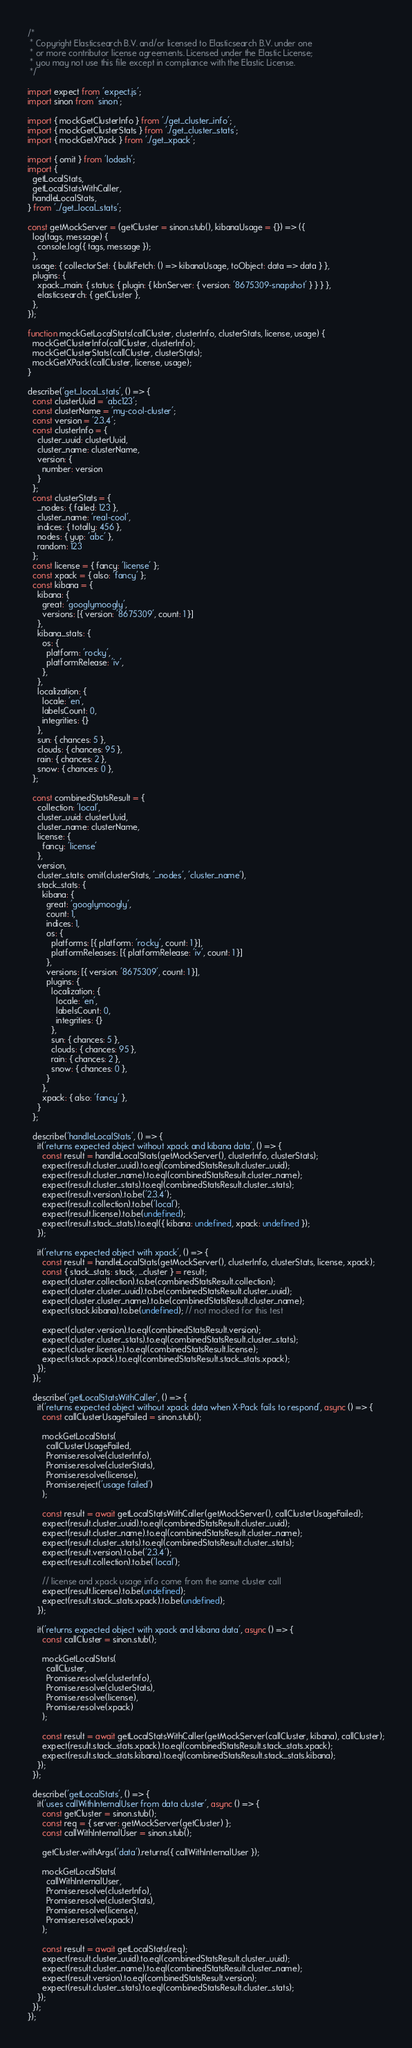<code> <loc_0><loc_0><loc_500><loc_500><_JavaScript_>/*
 * Copyright Elasticsearch B.V. and/or licensed to Elasticsearch B.V. under one
 * or more contributor license agreements. Licensed under the Elastic License;
 * you may not use this file except in compliance with the Elastic License.
 */

import expect from 'expect.js';
import sinon from 'sinon';

import { mockGetClusterInfo } from './get_cluster_info';
import { mockGetClusterStats } from './get_cluster_stats';
import { mockGetXPack } from './get_xpack';

import { omit } from 'lodash';
import {
  getLocalStats,
  getLocalStatsWithCaller,
  handleLocalStats,
} from '../get_local_stats';

const getMockServer = (getCluster = sinon.stub(), kibanaUsage = {}) => ({
  log(tags, message) {
    console.log({ tags, message });
  },
  usage: { collectorSet: { bulkFetch: () => kibanaUsage, toObject: data => data } },
  plugins: {
    xpack_main: { status: { plugin: { kbnServer: { version: '8675309-snapshot' } } } },
    elasticsearch: { getCluster },
  },
});

function mockGetLocalStats(callCluster, clusterInfo, clusterStats, license, usage) {
  mockGetClusterInfo(callCluster, clusterInfo);
  mockGetClusterStats(callCluster, clusterStats);
  mockGetXPack(callCluster, license, usage);
}

describe('get_local_stats', () => {
  const clusterUuid = 'abc123';
  const clusterName = 'my-cool-cluster';
  const version = '2.3.4';
  const clusterInfo = {
    cluster_uuid: clusterUuid,
    cluster_name: clusterName,
    version: {
      number: version
    }
  };
  const clusterStats = {
    _nodes: { failed: 123 },
    cluster_name: 'real-cool',
    indices: { totally: 456 },
    nodes: { yup: 'abc' },
    random: 123
  };
  const license = { fancy: 'license' };
  const xpack = { also: 'fancy' };
  const kibana = {
    kibana: {
      great: 'googlymoogly',
      versions: [{ version: '8675309', count: 1 }]
    },
    kibana_stats: {
      os: {
        platform: 'rocky',
        platformRelease: 'iv',
      },
    },
    localization: {
      locale: 'en',
      labelsCount: 0,
      integrities: {}
    },
    sun: { chances: 5 },
    clouds: { chances: 95 },
    rain: { chances: 2 },
    snow: { chances: 0 },
  };

  const combinedStatsResult = {
    collection: 'local',
    cluster_uuid: clusterUuid,
    cluster_name: clusterName,
    license: {
      fancy: 'license'
    },
    version,
    cluster_stats: omit(clusterStats, '_nodes', 'cluster_name'),
    stack_stats: {
      kibana: {
        great: 'googlymoogly',
        count: 1,
        indices: 1,
        os: {
          platforms: [{ platform: 'rocky', count: 1 }],
          platformReleases: [{ platformRelease: 'iv', count: 1 }]
        },
        versions: [{ version: '8675309', count: 1 }],
        plugins: {
          localization: {
            locale: 'en',
            labelsCount: 0,
            integrities: {}
          },
          sun: { chances: 5 },
          clouds: { chances: 95 },
          rain: { chances: 2 },
          snow: { chances: 0 },
        }
      },
      xpack: { also: 'fancy' },
    }
  };

  describe('handleLocalStats', () => {
    it('returns expected object without xpack and kibana data', () => {
      const result = handleLocalStats(getMockServer(), clusterInfo, clusterStats);
      expect(result.cluster_uuid).to.eql(combinedStatsResult.cluster_uuid);
      expect(result.cluster_name).to.eql(combinedStatsResult.cluster_name);
      expect(result.cluster_stats).to.eql(combinedStatsResult.cluster_stats);
      expect(result.version).to.be('2.3.4');
      expect(result.collection).to.be('local');
      expect(result.license).to.be(undefined);
      expect(result.stack_stats).to.eql({ kibana: undefined, xpack: undefined });
    });

    it('returns expected object with xpack', () => {
      const result = handleLocalStats(getMockServer(), clusterInfo, clusterStats, license, xpack);
      const { stack_stats: stack, ...cluster } = result;
      expect(cluster.collection).to.be(combinedStatsResult.collection);
      expect(cluster.cluster_uuid).to.be(combinedStatsResult.cluster_uuid);
      expect(cluster.cluster_name).to.be(combinedStatsResult.cluster_name);
      expect(stack.kibana).to.be(undefined); // not mocked for this test

      expect(cluster.version).to.eql(combinedStatsResult.version);
      expect(cluster.cluster_stats).to.eql(combinedStatsResult.cluster_stats);
      expect(cluster.license).to.eql(combinedStatsResult.license);
      expect(stack.xpack).to.eql(combinedStatsResult.stack_stats.xpack);
    });
  });

  describe('getLocalStatsWithCaller', () => {
    it('returns expected object without xpack data when X-Pack fails to respond', async () => {
      const callClusterUsageFailed = sinon.stub();

      mockGetLocalStats(
        callClusterUsageFailed,
        Promise.resolve(clusterInfo),
        Promise.resolve(clusterStats),
        Promise.resolve(license),
        Promise.reject('usage failed')
      );

      const result = await getLocalStatsWithCaller(getMockServer(), callClusterUsageFailed);
      expect(result.cluster_uuid).to.eql(combinedStatsResult.cluster_uuid);
      expect(result.cluster_name).to.eql(combinedStatsResult.cluster_name);
      expect(result.cluster_stats).to.eql(combinedStatsResult.cluster_stats);
      expect(result.version).to.be('2.3.4');
      expect(result.collection).to.be('local');

      // license and xpack usage info come from the same cluster call
      expect(result.license).to.be(undefined);
      expect(result.stack_stats.xpack).to.be(undefined);
    });

    it('returns expected object with xpack and kibana data', async () => {
      const callCluster = sinon.stub();

      mockGetLocalStats(
        callCluster,
        Promise.resolve(clusterInfo),
        Promise.resolve(clusterStats),
        Promise.resolve(license),
        Promise.resolve(xpack)
      );

      const result = await getLocalStatsWithCaller(getMockServer(callCluster, kibana), callCluster);
      expect(result.stack_stats.xpack).to.eql(combinedStatsResult.stack_stats.xpack);
      expect(result.stack_stats.kibana).to.eql(combinedStatsResult.stack_stats.kibana);
    });
  });

  describe('getLocalStats', () => {
    it('uses callWithInternalUser from data cluster', async () => {
      const getCluster = sinon.stub();
      const req = { server: getMockServer(getCluster) };
      const callWithInternalUser = sinon.stub();

      getCluster.withArgs('data').returns({ callWithInternalUser });

      mockGetLocalStats(
        callWithInternalUser,
        Promise.resolve(clusterInfo),
        Promise.resolve(clusterStats),
        Promise.resolve(license),
        Promise.resolve(xpack)
      );

      const result = await getLocalStats(req);
      expect(result.cluster_uuid).to.eql(combinedStatsResult.cluster_uuid);
      expect(result.cluster_name).to.eql(combinedStatsResult.cluster_name);
      expect(result.version).to.eql(combinedStatsResult.version);
      expect(result.cluster_stats).to.eql(combinedStatsResult.cluster_stats);
    });
  });
});
</code> 